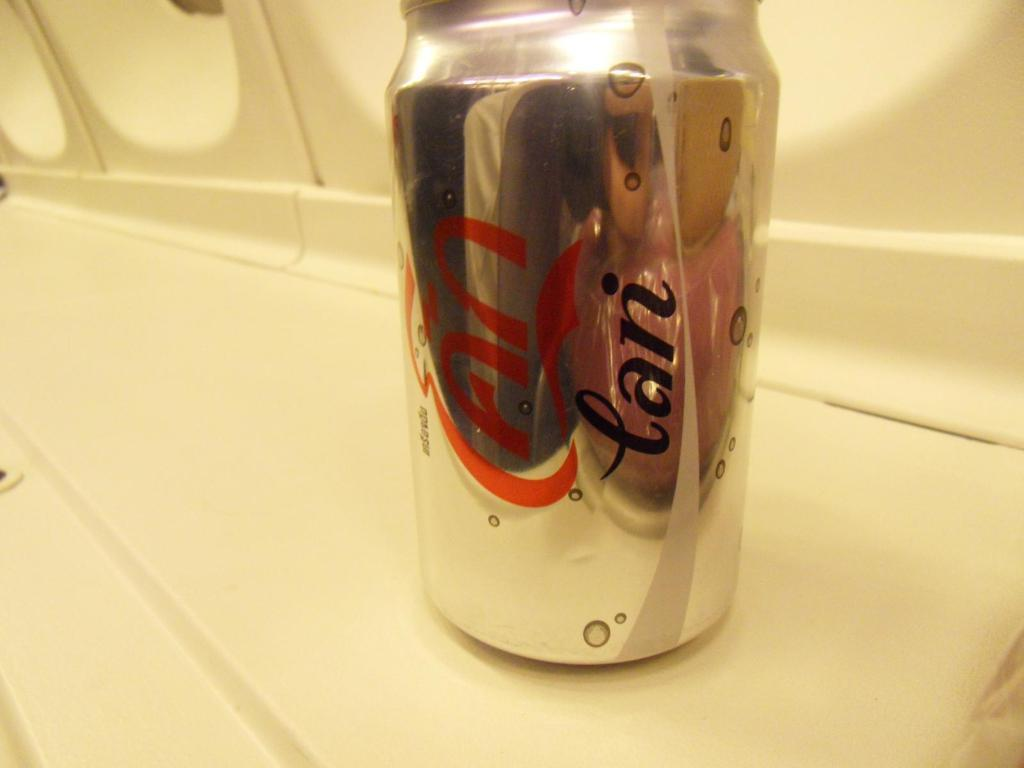<image>
Share a concise interpretation of the image provided. A red and silver can that says tan sitting on a table. 